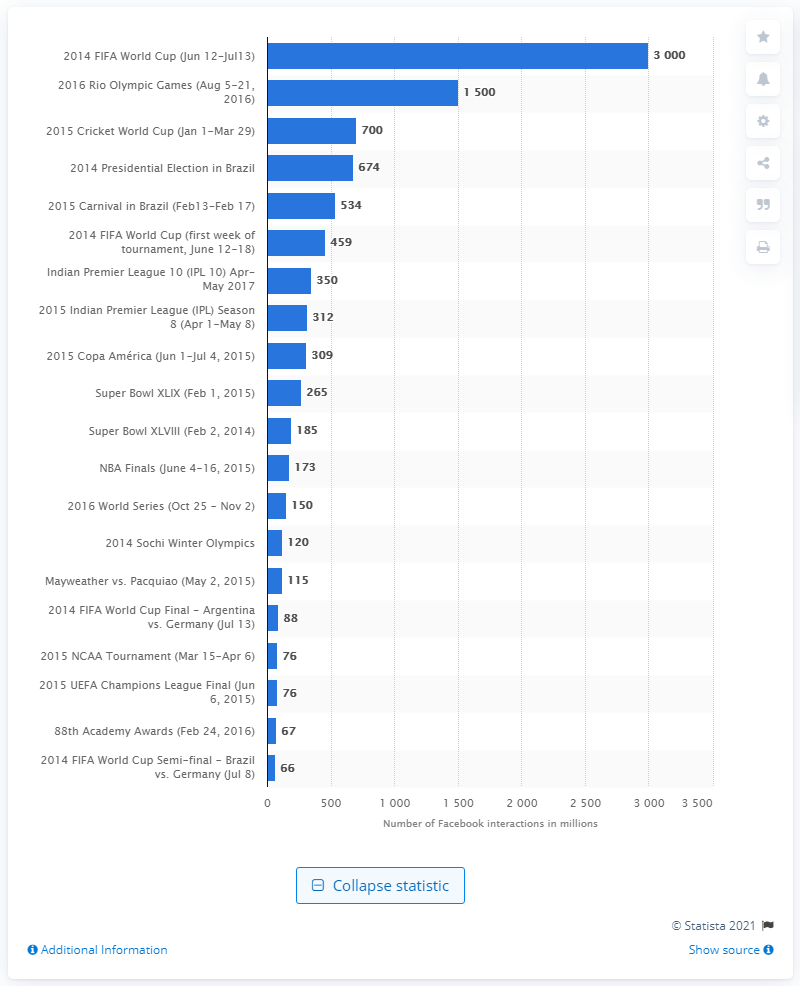Point out several critical features in this image. The 2014 FIFA World Cup generated approximately 3,000 Facebook interactions. The 2016 Rio Olympic Games had a total of 1,500 Facebook interactions. 